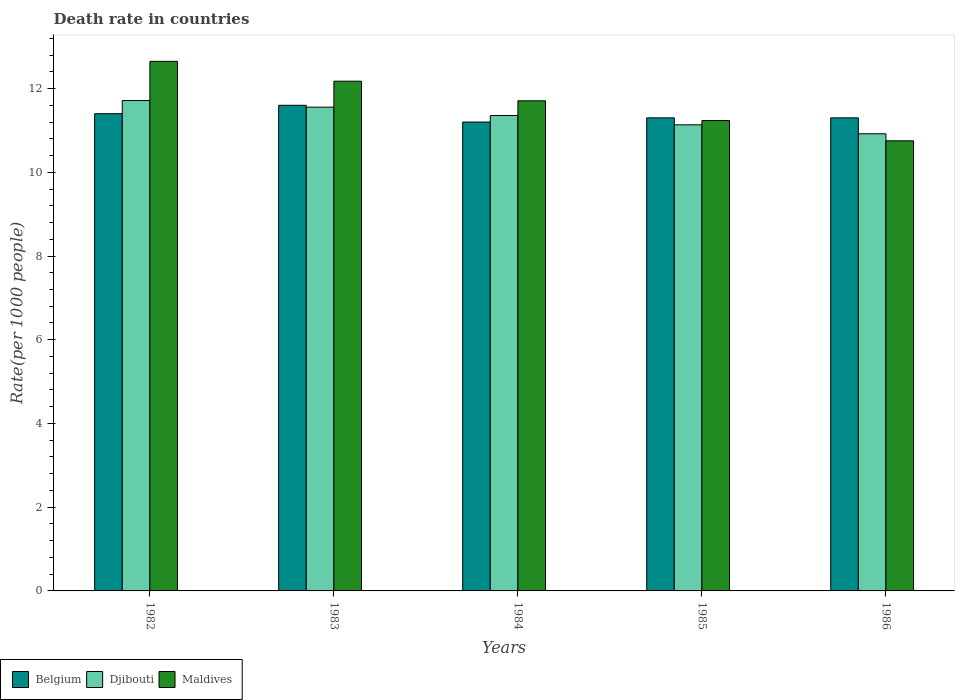How many groups of bars are there?
Your answer should be compact. 5. How many bars are there on the 1st tick from the left?
Give a very brief answer. 3. How many bars are there on the 2nd tick from the right?
Keep it short and to the point. 3. What is the label of the 1st group of bars from the left?
Your answer should be very brief. 1982. In how many cases, is the number of bars for a given year not equal to the number of legend labels?
Your answer should be compact. 0. What is the death rate in Djibouti in 1985?
Offer a very short reply. 11.13. Across all years, what is the maximum death rate in Djibouti?
Give a very brief answer. 11.71. Across all years, what is the minimum death rate in Belgium?
Offer a terse response. 11.2. In which year was the death rate in Djibouti maximum?
Ensure brevity in your answer.  1982. What is the total death rate in Belgium in the graph?
Provide a succinct answer. 56.8. What is the difference between the death rate in Belgium in 1984 and that in 1986?
Keep it short and to the point. -0.1. What is the difference between the death rate in Maldives in 1986 and the death rate in Djibouti in 1983?
Provide a short and direct response. -0.8. What is the average death rate in Belgium per year?
Ensure brevity in your answer.  11.36. In the year 1984, what is the difference between the death rate in Djibouti and death rate in Maldives?
Provide a short and direct response. -0.35. In how many years, is the death rate in Djibouti greater than 2.8?
Keep it short and to the point. 5. What is the ratio of the death rate in Belgium in 1982 to that in 1986?
Make the answer very short. 1.01. Is the difference between the death rate in Djibouti in 1985 and 1986 greater than the difference between the death rate in Maldives in 1985 and 1986?
Give a very brief answer. No. What is the difference between the highest and the second highest death rate in Djibouti?
Provide a succinct answer. 0.16. What is the difference between the highest and the lowest death rate in Belgium?
Offer a terse response. 0.4. In how many years, is the death rate in Djibouti greater than the average death rate in Djibouti taken over all years?
Keep it short and to the point. 3. What does the 1st bar from the left in 1985 represents?
Provide a short and direct response. Belgium. What does the 2nd bar from the right in 1982 represents?
Keep it short and to the point. Djibouti. Are all the bars in the graph horizontal?
Provide a succinct answer. No. What is the difference between two consecutive major ticks on the Y-axis?
Provide a succinct answer. 2. Does the graph contain any zero values?
Make the answer very short. No. Where does the legend appear in the graph?
Your answer should be very brief. Bottom left. How many legend labels are there?
Your answer should be very brief. 3. How are the legend labels stacked?
Your response must be concise. Horizontal. What is the title of the graph?
Ensure brevity in your answer.  Death rate in countries. Does "Small states" appear as one of the legend labels in the graph?
Offer a terse response. No. What is the label or title of the X-axis?
Offer a very short reply. Years. What is the label or title of the Y-axis?
Provide a succinct answer. Rate(per 1000 people). What is the Rate(per 1000 people) in Belgium in 1982?
Your response must be concise. 11.4. What is the Rate(per 1000 people) in Djibouti in 1982?
Keep it short and to the point. 11.71. What is the Rate(per 1000 people) of Maldives in 1982?
Keep it short and to the point. 12.65. What is the Rate(per 1000 people) of Djibouti in 1983?
Provide a succinct answer. 11.56. What is the Rate(per 1000 people) in Maldives in 1983?
Provide a short and direct response. 12.18. What is the Rate(per 1000 people) in Djibouti in 1984?
Make the answer very short. 11.36. What is the Rate(per 1000 people) of Maldives in 1984?
Your answer should be compact. 11.71. What is the Rate(per 1000 people) in Djibouti in 1985?
Give a very brief answer. 11.13. What is the Rate(per 1000 people) in Maldives in 1985?
Keep it short and to the point. 11.24. What is the Rate(per 1000 people) of Djibouti in 1986?
Your response must be concise. 10.92. What is the Rate(per 1000 people) of Maldives in 1986?
Keep it short and to the point. 10.75. Across all years, what is the maximum Rate(per 1000 people) in Belgium?
Your answer should be very brief. 11.6. Across all years, what is the maximum Rate(per 1000 people) of Djibouti?
Give a very brief answer. 11.71. Across all years, what is the maximum Rate(per 1000 people) in Maldives?
Your answer should be compact. 12.65. Across all years, what is the minimum Rate(per 1000 people) in Djibouti?
Offer a terse response. 10.92. Across all years, what is the minimum Rate(per 1000 people) of Maldives?
Make the answer very short. 10.75. What is the total Rate(per 1000 people) of Belgium in the graph?
Make the answer very short. 56.8. What is the total Rate(per 1000 people) in Djibouti in the graph?
Your answer should be compact. 56.68. What is the total Rate(per 1000 people) in Maldives in the graph?
Provide a succinct answer. 58.52. What is the difference between the Rate(per 1000 people) in Djibouti in 1982 and that in 1983?
Offer a terse response. 0.16. What is the difference between the Rate(per 1000 people) in Maldives in 1982 and that in 1983?
Provide a short and direct response. 0.47. What is the difference between the Rate(per 1000 people) in Djibouti in 1982 and that in 1984?
Ensure brevity in your answer.  0.36. What is the difference between the Rate(per 1000 people) of Maldives in 1982 and that in 1984?
Make the answer very short. 0.94. What is the difference between the Rate(per 1000 people) in Djibouti in 1982 and that in 1985?
Your response must be concise. 0.58. What is the difference between the Rate(per 1000 people) of Maldives in 1982 and that in 1985?
Provide a short and direct response. 1.41. What is the difference between the Rate(per 1000 people) in Djibouti in 1982 and that in 1986?
Your answer should be very brief. 0.79. What is the difference between the Rate(per 1000 people) of Maldives in 1982 and that in 1986?
Your answer should be very brief. 1.9. What is the difference between the Rate(per 1000 people) of Djibouti in 1983 and that in 1984?
Your answer should be compact. 0.2. What is the difference between the Rate(per 1000 people) of Maldives in 1983 and that in 1984?
Provide a short and direct response. 0.47. What is the difference between the Rate(per 1000 people) in Djibouti in 1983 and that in 1985?
Provide a short and direct response. 0.42. What is the difference between the Rate(per 1000 people) of Belgium in 1983 and that in 1986?
Provide a short and direct response. 0.3. What is the difference between the Rate(per 1000 people) in Djibouti in 1983 and that in 1986?
Offer a very short reply. 0.64. What is the difference between the Rate(per 1000 people) of Maldives in 1983 and that in 1986?
Ensure brevity in your answer.  1.42. What is the difference between the Rate(per 1000 people) of Belgium in 1984 and that in 1985?
Your response must be concise. -0.1. What is the difference between the Rate(per 1000 people) in Djibouti in 1984 and that in 1985?
Offer a very short reply. 0.22. What is the difference between the Rate(per 1000 people) of Maldives in 1984 and that in 1985?
Provide a short and direct response. 0.47. What is the difference between the Rate(per 1000 people) of Belgium in 1984 and that in 1986?
Provide a succinct answer. -0.1. What is the difference between the Rate(per 1000 people) of Djibouti in 1984 and that in 1986?
Give a very brief answer. 0.44. What is the difference between the Rate(per 1000 people) in Maldives in 1984 and that in 1986?
Provide a succinct answer. 0.96. What is the difference between the Rate(per 1000 people) in Belgium in 1985 and that in 1986?
Provide a short and direct response. 0. What is the difference between the Rate(per 1000 people) in Djibouti in 1985 and that in 1986?
Offer a terse response. 0.21. What is the difference between the Rate(per 1000 people) of Maldives in 1985 and that in 1986?
Give a very brief answer. 0.48. What is the difference between the Rate(per 1000 people) in Belgium in 1982 and the Rate(per 1000 people) in Djibouti in 1983?
Your response must be concise. -0.16. What is the difference between the Rate(per 1000 people) of Belgium in 1982 and the Rate(per 1000 people) of Maldives in 1983?
Provide a short and direct response. -0.78. What is the difference between the Rate(per 1000 people) of Djibouti in 1982 and the Rate(per 1000 people) of Maldives in 1983?
Give a very brief answer. -0.46. What is the difference between the Rate(per 1000 people) of Belgium in 1982 and the Rate(per 1000 people) of Djibouti in 1984?
Your response must be concise. 0.04. What is the difference between the Rate(per 1000 people) in Belgium in 1982 and the Rate(per 1000 people) in Maldives in 1984?
Provide a short and direct response. -0.31. What is the difference between the Rate(per 1000 people) in Djibouti in 1982 and the Rate(per 1000 people) in Maldives in 1984?
Your answer should be very brief. 0.01. What is the difference between the Rate(per 1000 people) of Belgium in 1982 and the Rate(per 1000 people) of Djibouti in 1985?
Offer a very short reply. 0.27. What is the difference between the Rate(per 1000 people) of Belgium in 1982 and the Rate(per 1000 people) of Maldives in 1985?
Provide a short and direct response. 0.16. What is the difference between the Rate(per 1000 people) in Djibouti in 1982 and the Rate(per 1000 people) in Maldives in 1985?
Offer a very short reply. 0.48. What is the difference between the Rate(per 1000 people) in Belgium in 1982 and the Rate(per 1000 people) in Djibouti in 1986?
Your response must be concise. 0.48. What is the difference between the Rate(per 1000 people) in Belgium in 1982 and the Rate(per 1000 people) in Maldives in 1986?
Provide a short and direct response. 0.65. What is the difference between the Rate(per 1000 people) in Belgium in 1983 and the Rate(per 1000 people) in Djibouti in 1984?
Your answer should be very brief. 0.24. What is the difference between the Rate(per 1000 people) of Belgium in 1983 and the Rate(per 1000 people) of Maldives in 1984?
Offer a very short reply. -0.11. What is the difference between the Rate(per 1000 people) in Djibouti in 1983 and the Rate(per 1000 people) in Maldives in 1984?
Your response must be concise. -0.15. What is the difference between the Rate(per 1000 people) in Belgium in 1983 and the Rate(per 1000 people) in Djibouti in 1985?
Provide a succinct answer. 0.47. What is the difference between the Rate(per 1000 people) of Belgium in 1983 and the Rate(per 1000 people) of Maldives in 1985?
Offer a terse response. 0.36. What is the difference between the Rate(per 1000 people) of Djibouti in 1983 and the Rate(per 1000 people) of Maldives in 1985?
Offer a terse response. 0.32. What is the difference between the Rate(per 1000 people) of Belgium in 1983 and the Rate(per 1000 people) of Djibouti in 1986?
Offer a very short reply. 0.68. What is the difference between the Rate(per 1000 people) of Belgium in 1983 and the Rate(per 1000 people) of Maldives in 1986?
Make the answer very short. 0.85. What is the difference between the Rate(per 1000 people) in Djibouti in 1983 and the Rate(per 1000 people) in Maldives in 1986?
Make the answer very short. 0.8. What is the difference between the Rate(per 1000 people) of Belgium in 1984 and the Rate(per 1000 people) of Djibouti in 1985?
Your answer should be very brief. 0.07. What is the difference between the Rate(per 1000 people) of Belgium in 1984 and the Rate(per 1000 people) of Maldives in 1985?
Your response must be concise. -0.04. What is the difference between the Rate(per 1000 people) in Djibouti in 1984 and the Rate(per 1000 people) in Maldives in 1985?
Give a very brief answer. 0.12. What is the difference between the Rate(per 1000 people) in Belgium in 1984 and the Rate(per 1000 people) in Djibouti in 1986?
Offer a very short reply. 0.28. What is the difference between the Rate(per 1000 people) in Belgium in 1984 and the Rate(per 1000 people) in Maldives in 1986?
Provide a short and direct response. 0.45. What is the difference between the Rate(per 1000 people) in Djibouti in 1984 and the Rate(per 1000 people) in Maldives in 1986?
Keep it short and to the point. 0.6. What is the difference between the Rate(per 1000 people) in Belgium in 1985 and the Rate(per 1000 people) in Djibouti in 1986?
Ensure brevity in your answer.  0.38. What is the difference between the Rate(per 1000 people) of Belgium in 1985 and the Rate(per 1000 people) of Maldives in 1986?
Provide a succinct answer. 0.55. What is the difference between the Rate(per 1000 people) of Djibouti in 1985 and the Rate(per 1000 people) of Maldives in 1986?
Your response must be concise. 0.38. What is the average Rate(per 1000 people) of Belgium per year?
Provide a short and direct response. 11.36. What is the average Rate(per 1000 people) of Djibouti per year?
Offer a terse response. 11.34. What is the average Rate(per 1000 people) of Maldives per year?
Ensure brevity in your answer.  11.7. In the year 1982, what is the difference between the Rate(per 1000 people) of Belgium and Rate(per 1000 people) of Djibouti?
Give a very brief answer. -0.31. In the year 1982, what is the difference between the Rate(per 1000 people) of Belgium and Rate(per 1000 people) of Maldives?
Provide a short and direct response. -1.25. In the year 1982, what is the difference between the Rate(per 1000 people) of Djibouti and Rate(per 1000 people) of Maldives?
Offer a very short reply. -0.94. In the year 1983, what is the difference between the Rate(per 1000 people) in Belgium and Rate(per 1000 people) in Djibouti?
Ensure brevity in your answer.  0.04. In the year 1983, what is the difference between the Rate(per 1000 people) in Belgium and Rate(per 1000 people) in Maldives?
Make the answer very short. -0.58. In the year 1983, what is the difference between the Rate(per 1000 people) of Djibouti and Rate(per 1000 people) of Maldives?
Your answer should be very brief. -0.62. In the year 1984, what is the difference between the Rate(per 1000 people) in Belgium and Rate(per 1000 people) in Djibouti?
Provide a short and direct response. -0.16. In the year 1984, what is the difference between the Rate(per 1000 people) of Belgium and Rate(per 1000 people) of Maldives?
Give a very brief answer. -0.51. In the year 1984, what is the difference between the Rate(per 1000 people) in Djibouti and Rate(per 1000 people) in Maldives?
Provide a short and direct response. -0.35. In the year 1985, what is the difference between the Rate(per 1000 people) in Belgium and Rate(per 1000 people) in Djibouti?
Make the answer very short. 0.17. In the year 1985, what is the difference between the Rate(per 1000 people) of Belgium and Rate(per 1000 people) of Maldives?
Keep it short and to the point. 0.06. In the year 1985, what is the difference between the Rate(per 1000 people) in Djibouti and Rate(per 1000 people) in Maldives?
Your answer should be compact. -0.1. In the year 1986, what is the difference between the Rate(per 1000 people) in Belgium and Rate(per 1000 people) in Djibouti?
Your answer should be compact. 0.38. In the year 1986, what is the difference between the Rate(per 1000 people) in Belgium and Rate(per 1000 people) in Maldives?
Your answer should be compact. 0.55. In the year 1986, what is the difference between the Rate(per 1000 people) in Djibouti and Rate(per 1000 people) in Maldives?
Your answer should be compact. 0.17. What is the ratio of the Rate(per 1000 people) of Belgium in 1982 to that in 1983?
Give a very brief answer. 0.98. What is the ratio of the Rate(per 1000 people) of Djibouti in 1982 to that in 1983?
Provide a succinct answer. 1.01. What is the ratio of the Rate(per 1000 people) in Maldives in 1982 to that in 1983?
Keep it short and to the point. 1.04. What is the ratio of the Rate(per 1000 people) of Belgium in 1982 to that in 1984?
Keep it short and to the point. 1.02. What is the ratio of the Rate(per 1000 people) of Djibouti in 1982 to that in 1984?
Ensure brevity in your answer.  1.03. What is the ratio of the Rate(per 1000 people) of Maldives in 1982 to that in 1984?
Ensure brevity in your answer.  1.08. What is the ratio of the Rate(per 1000 people) of Belgium in 1982 to that in 1985?
Your answer should be compact. 1.01. What is the ratio of the Rate(per 1000 people) of Djibouti in 1982 to that in 1985?
Your answer should be very brief. 1.05. What is the ratio of the Rate(per 1000 people) in Maldives in 1982 to that in 1985?
Make the answer very short. 1.13. What is the ratio of the Rate(per 1000 people) of Belgium in 1982 to that in 1986?
Give a very brief answer. 1.01. What is the ratio of the Rate(per 1000 people) of Djibouti in 1982 to that in 1986?
Your answer should be compact. 1.07. What is the ratio of the Rate(per 1000 people) of Maldives in 1982 to that in 1986?
Ensure brevity in your answer.  1.18. What is the ratio of the Rate(per 1000 people) in Belgium in 1983 to that in 1984?
Make the answer very short. 1.04. What is the ratio of the Rate(per 1000 people) of Djibouti in 1983 to that in 1984?
Give a very brief answer. 1.02. What is the ratio of the Rate(per 1000 people) in Belgium in 1983 to that in 1985?
Your response must be concise. 1.03. What is the ratio of the Rate(per 1000 people) of Djibouti in 1983 to that in 1985?
Offer a very short reply. 1.04. What is the ratio of the Rate(per 1000 people) of Maldives in 1983 to that in 1985?
Offer a very short reply. 1.08. What is the ratio of the Rate(per 1000 people) of Belgium in 1983 to that in 1986?
Your response must be concise. 1.03. What is the ratio of the Rate(per 1000 people) of Djibouti in 1983 to that in 1986?
Ensure brevity in your answer.  1.06. What is the ratio of the Rate(per 1000 people) in Maldives in 1983 to that in 1986?
Keep it short and to the point. 1.13. What is the ratio of the Rate(per 1000 people) in Maldives in 1984 to that in 1985?
Provide a succinct answer. 1.04. What is the ratio of the Rate(per 1000 people) of Belgium in 1984 to that in 1986?
Provide a short and direct response. 0.99. What is the ratio of the Rate(per 1000 people) of Maldives in 1984 to that in 1986?
Provide a short and direct response. 1.09. What is the ratio of the Rate(per 1000 people) of Djibouti in 1985 to that in 1986?
Give a very brief answer. 1.02. What is the ratio of the Rate(per 1000 people) of Maldives in 1985 to that in 1986?
Offer a terse response. 1.04. What is the difference between the highest and the second highest Rate(per 1000 people) of Belgium?
Your response must be concise. 0.2. What is the difference between the highest and the second highest Rate(per 1000 people) in Djibouti?
Offer a very short reply. 0.16. What is the difference between the highest and the second highest Rate(per 1000 people) in Maldives?
Ensure brevity in your answer.  0.47. What is the difference between the highest and the lowest Rate(per 1000 people) in Belgium?
Offer a terse response. 0.4. What is the difference between the highest and the lowest Rate(per 1000 people) in Djibouti?
Keep it short and to the point. 0.79. What is the difference between the highest and the lowest Rate(per 1000 people) of Maldives?
Provide a short and direct response. 1.9. 